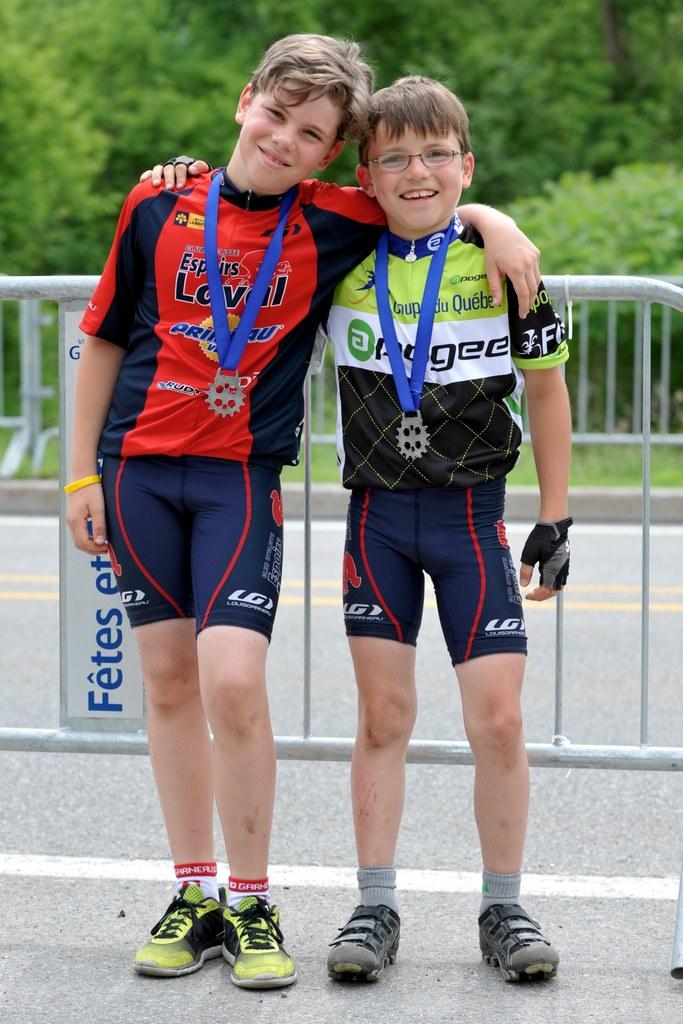What is the brand mentioned on the red shirt?
Make the answer very short. Rudy. What is the brand on green shirt?
Provide a succinct answer. Pogee. 